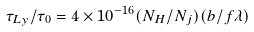<formula> <loc_0><loc_0><loc_500><loc_500>\tau _ { L y } / \tau _ { 0 } = 4 \times 1 0 ^ { - 1 6 } ( N _ { H } / N _ { j } ) ( b / f \lambda )</formula> 